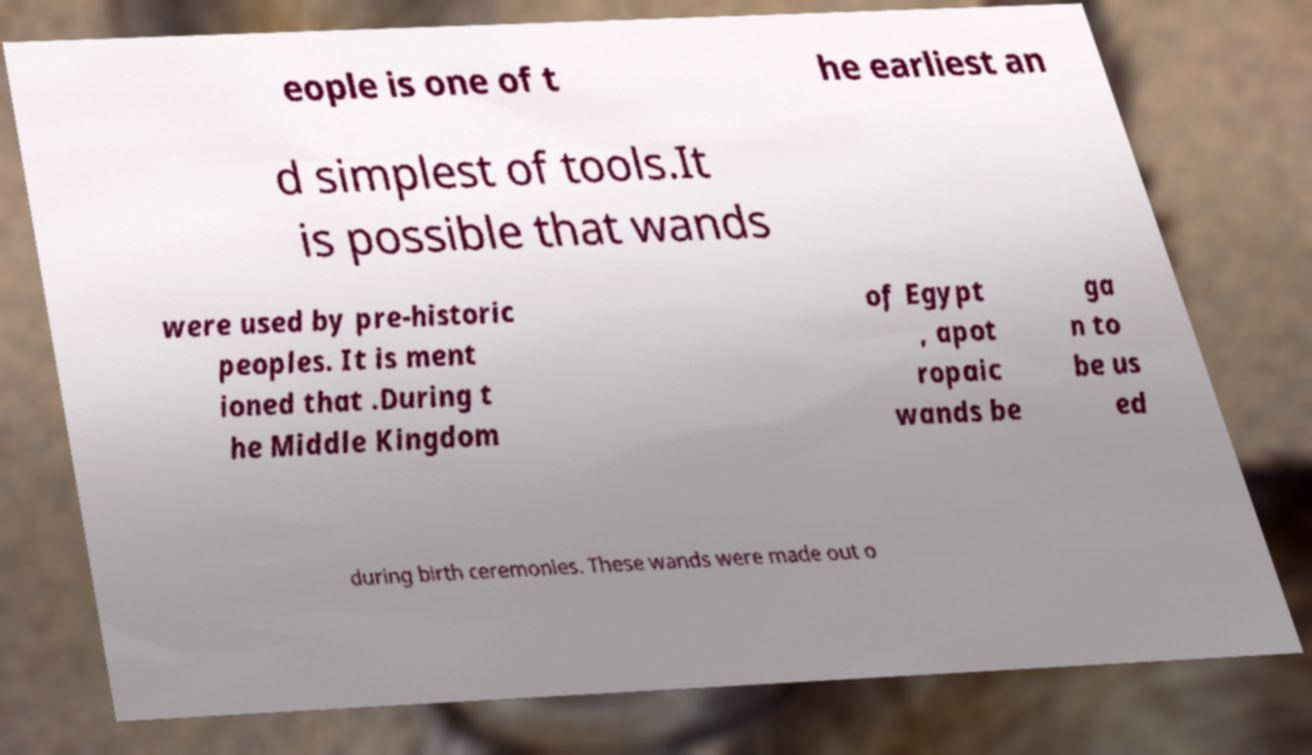Can you accurately transcribe the text from the provided image for me? eople is one of t he earliest an d simplest of tools.It is possible that wands were used by pre-historic peoples. It is ment ioned that .During t he Middle Kingdom of Egypt , apot ropaic wands be ga n to be us ed during birth ceremonies. These wands were made out o 